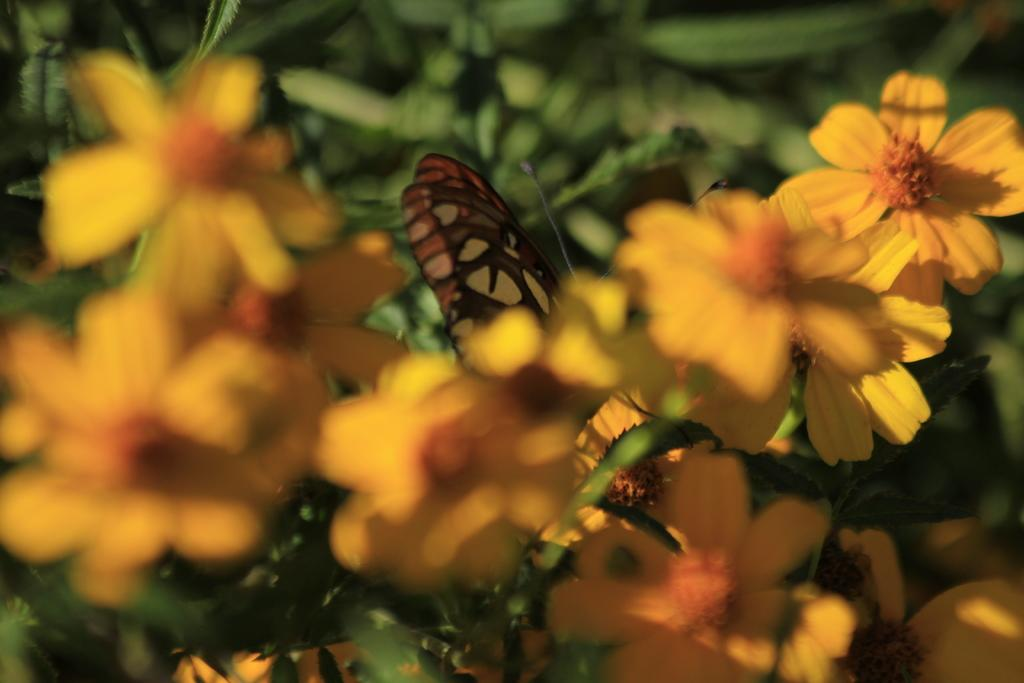What is present in the image? There is a plant in the image. What distinguishing feature can be observed about the plant? The plant has yellow flowers. What type of holiday is the dad celebrating with the plant in the image? There is no dad or holiday present in the image; it only features a plant with yellow flowers. What type of clam can be seen interacting with the plant in the image? There is no clam present in the image; it only features a plant with yellow flowers. 